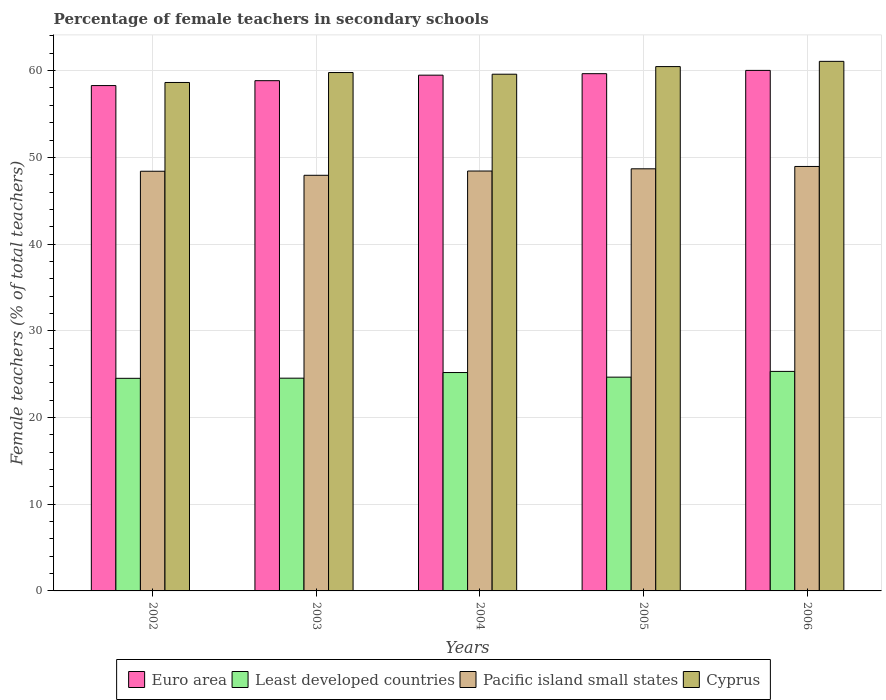How many different coloured bars are there?
Give a very brief answer. 4. Are the number of bars on each tick of the X-axis equal?
Offer a terse response. Yes. How many bars are there on the 5th tick from the left?
Offer a very short reply. 4. What is the label of the 1st group of bars from the left?
Make the answer very short. 2002. In how many cases, is the number of bars for a given year not equal to the number of legend labels?
Provide a short and direct response. 0. What is the percentage of female teachers in Euro area in 2004?
Your answer should be very brief. 59.48. Across all years, what is the maximum percentage of female teachers in Cyprus?
Offer a very short reply. 61.07. Across all years, what is the minimum percentage of female teachers in Least developed countries?
Provide a succinct answer. 24.52. In which year was the percentage of female teachers in Euro area maximum?
Offer a very short reply. 2006. What is the total percentage of female teachers in Least developed countries in the graph?
Provide a short and direct response. 124.2. What is the difference between the percentage of female teachers in Least developed countries in 2002 and that in 2003?
Keep it short and to the point. -0.02. What is the difference between the percentage of female teachers in Least developed countries in 2003 and the percentage of female teachers in Euro area in 2004?
Make the answer very short. -34.94. What is the average percentage of female teachers in Cyprus per year?
Offer a very short reply. 59.91. In the year 2006, what is the difference between the percentage of female teachers in Pacific island small states and percentage of female teachers in Cyprus?
Provide a short and direct response. -12.12. What is the ratio of the percentage of female teachers in Least developed countries in 2003 to that in 2004?
Offer a terse response. 0.97. Is the percentage of female teachers in Least developed countries in 2002 less than that in 2004?
Keep it short and to the point. Yes. Is the difference between the percentage of female teachers in Pacific island small states in 2003 and 2006 greater than the difference between the percentage of female teachers in Cyprus in 2003 and 2006?
Your response must be concise. Yes. What is the difference between the highest and the second highest percentage of female teachers in Cyprus?
Your answer should be very brief. 0.6. What is the difference between the highest and the lowest percentage of female teachers in Cyprus?
Your answer should be very brief. 2.44. In how many years, is the percentage of female teachers in Pacific island small states greater than the average percentage of female teachers in Pacific island small states taken over all years?
Make the answer very short. 2. What does the 2nd bar from the left in 2006 represents?
Offer a very short reply. Least developed countries. What does the 2nd bar from the right in 2003 represents?
Keep it short and to the point. Pacific island small states. Are all the bars in the graph horizontal?
Ensure brevity in your answer.  No. How many years are there in the graph?
Ensure brevity in your answer.  5. What is the difference between two consecutive major ticks on the Y-axis?
Provide a short and direct response. 10. Are the values on the major ticks of Y-axis written in scientific E-notation?
Your answer should be very brief. No. Does the graph contain grids?
Offer a very short reply. Yes. Where does the legend appear in the graph?
Your response must be concise. Bottom center. How many legend labels are there?
Your answer should be compact. 4. How are the legend labels stacked?
Ensure brevity in your answer.  Horizontal. What is the title of the graph?
Your response must be concise. Percentage of female teachers in secondary schools. What is the label or title of the Y-axis?
Make the answer very short. Female teachers (% of total teachers). What is the Female teachers (% of total teachers) in Euro area in 2002?
Ensure brevity in your answer.  58.28. What is the Female teachers (% of total teachers) in Least developed countries in 2002?
Provide a succinct answer. 24.52. What is the Female teachers (% of total teachers) in Pacific island small states in 2002?
Your answer should be compact. 48.4. What is the Female teachers (% of total teachers) in Cyprus in 2002?
Your response must be concise. 58.63. What is the Female teachers (% of total teachers) in Euro area in 2003?
Offer a terse response. 58.84. What is the Female teachers (% of total teachers) of Least developed countries in 2003?
Offer a terse response. 24.53. What is the Female teachers (% of total teachers) of Pacific island small states in 2003?
Provide a short and direct response. 47.93. What is the Female teachers (% of total teachers) in Cyprus in 2003?
Your answer should be compact. 59.78. What is the Female teachers (% of total teachers) of Euro area in 2004?
Provide a succinct answer. 59.48. What is the Female teachers (% of total teachers) in Least developed countries in 2004?
Your answer should be compact. 25.18. What is the Female teachers (% of total teachers) in Pacific island small states in 2004?
Provide a succinct answer. 48.42. What is the Female teachers (% of total teachers) of Cyprus in 2004?
Your answer should be very brief. 59.59. What is the Female teachers (% of total teachers) of Euro area in 2005?
Make the answer very short. 59.65. What is the Female teachers (% of total teachers) of Least developed countries in 2005?
Offer a terse response. 24.65. What is the Female teachers (% of total teachers) of Pacific island small states in 2005?
Offer a very short reply. 48.68. What is the Female teachers (% of total teachers) in Cyprus in 2005?
Offer a terse response. 60.47. What is the Female teachers (% of total teachers) in Euro area in 2006?
Provide a short and direct response. 60.03. What is the Female teachers (% of total teachers) in Least developed countries in 2006?
Offer a terse response. 25.32. What is the Female teachers (% of total teachers) of Pacific island small states in 2006?
Give a very brief answer. 48.95. What is the Female teachers (% of total teachers) of Cyprus in 2006?
Your response must be concise. 61.07. Across all years, what is the maximum Female teachers (% of total teachers) in Euro area?
Your answer should be compact. 60.03. Across all years, what is the maximum Female teachers (% of total teachers) in Least developed countries?
Make the answer very short. 25.32. Across all years, what is the maximum Female teachers (% of total teachers) of Pacific island small states?
Your answer should be very brief. 48.95. Across all years, what is the maximum Female teachers (% of total teachers) in Cyprus?
Your response must be concise. 61.07. Across all years, what is the minimum Female teachers (% of total teachers) in Euro area?
Your answer should be very brief. 58.28. Across all years, what is the minimum Female teachers (% of total teachers) of Least developed countries?
Your answer should be compact. 24.52. Across all years, what is the minimum Female teachers (% of total teachers) in Pacific island small states?
Offer a very short reply. 47.93. Across all years, what is the minimum Female teachers (% of total teachers) in Cyprus?
Your response must be concise. 58.63. What is the total Female teachers (% of total teachers) of Euro area in the graph?
Make the answer very short. 296.28. What is the total Female teachers (% of total teachers) of Least developed countries in the graph?
Offer a terse response. 124.2. What is the total Female teachers (% of total teachers) of Pacific island small states in the graph?
Make the answer very short. 242.38. What is the total Female teachers (% of total teachers) in Cyprus in the graph?
Your response must be concise. 299.54. What is the difference between the Female teachers (% of total teachers) in Euro area in 2002 and that in 2003?
Your answer should be compact. -0.56. What is the difference between the Female teachers (% of total teachers) of Least developed countries in 2002 and that in 2003?
Provide a short and direct response. -0.02. What is the difference between the Female teachers (% of total teachers) in Pacific island small states in 2002 and that in 2003?
Keep it short and to the point. 0.47. What is the difference between the Female teachers (% of total teachers) in Cyprus in 2002 and that in 2003?
Provide a short and direct response. -1.15. What is the difference between the Female teachers (% of total teachers) of Euro area in 2002 and that in 2004?
Provide a short and direct response. -1.2. What is the difference between the Female teachers (% of total teachers) in Least developed countries in 2002 and that in 2004?
Your response must be concise. -0.67. What is the difference between the Female teachers (% of total teachers) of Pacific island small states in 2002 and that in 2004?
Offer a terse response. -0.02. What is the difference between the Female teachers (% of total teachers) of Cyprus in 2002 and that in 2004?
Give a very brief answer. -0.95. What is the difference between the Female teachers (% of total teachers) in Euro area in 2002 and that in 2005?
Your response must be concise. -1.37. What is the difference between the Female teachers (% of total teachers) of Least developed countries in 2002 and that in 2005?
Your answer should be very brief. -0.13. What is the difference between the Female teachers (% of total teachers) in Pacific island small states in 2002 and that in 2005?
Ensure brevity in your answer.  -0.28. What is the difference between the Female teachers (% of total teachers) in Cyprus in 2002 and that in 2005?
Your response must be concise. -1.83. What is the difference between the Female teachers (% of total teachers) in Euro area in 2002 and that in 2006?
Give a very brief answer. -1.75. What is the difference between the Female teachers (% of total teachers) of Least developed countries in 2002 and that in 2006?
Provide a short and direct response. -0.8. What is the difference between the Female teachers (% of total teachers) of Pacific island small states in 2002 and that in 2006?
Offer a terse response. -0.55. What is the difference between the Female teachers (% of total teachers) in Cyprus in 2002 and that in 2006?
Provide a succinct answer. -2.44. What is the difference between the Female teachers (% of total teachers) of Euro area in 2003 and that in 2004?
Make the answer very short. -0.64. What is the difference between the Female teachers (% of total teachers) in Least developed countries in 2003 and that in 2004?
Give a very brief answer. -0.65. What is the difference between the Female teachers (% of total teachers) in Pacific island small states in 2003 and that in 2004?
Offer a very short reply. -0.49. What is the difference between the Female teachers (% of total teachers) in Cyprus in 2003 and that in 2004?
Give a very brief answer. 0.19. What is the difference between the Female teachers (% of total teachers) in Euro area in 2003 and that in 2005?
Provide a succinct answer. -0.81. What is the difference between the Female teachers (% of total teachers) of Least developed countries in 2003 and that in 2005?
Keep it short and to the point. -0.12. What is the difference between the Female teachers (% of total teachers) of Pacific island small states in 2003 and that in 2005?
Your response must be concise. -0.75. What is the difference between the Female teachers (% of total teachers) in Cyprus in 2003 and that in 2005?
Offer a terse response. -0.69. What is the difference between the Female teachers (% of total teachers) in Euro area in 2003 and that in 2006?
Keep it short and to the point. -1.19. What is the difference between the Female teachers (% of total teachers) in Least developed countries in 2003 and that in 2006?
Give a very brief answer. -0.78. What is the difference between the Female teachers (% of total teachers) in Pacific island small states in 2003 and that in 2006?
Provide a short and direct response. -1.02. What is the difference between the Female teachers (% of total teachers) of Cyprus in 2003 and that in 2006?
Offer a very short reply. -1.29. What is the difference between the Female teachers (% of total teachers) in Euro area in 2004 and that in 2005?
Provide a short and direct response. -0.17. What is the difference between the Female teachers (% of total teachers) of Least developed countries in 2004 and that in 2005?
Offer a very short reply. 0.53. What is the difference between the Female teachers (% of total teachers) of Pacific island small states in 2004 and that in 2005?
Your answer should be very brief. -0.26. What is the difference between the Female teachers (% of total teachers) in Cyprus in 2004 and that in 2005?
Give a very brief answer. -0.88. What is the difference between the Female teachers (% of total teachers) in Euro area in 2004 and that in 2006?
Your answer should be compact. -0.55. What is the difference between the Female teachers (% of total teachers) of Least developed countries in 2004 and that in 2006?
Your answer should be very brief. -0.13. What is the difference between the Female teachers (% of total teachers) in Pacific island small states in 2004 and that in 2006?
Provide a short and direct response. -0.53. What is the difference between the Female teachers (% of total teachers) of Cyprus in 2004 and that in 2006?
Your answer should be very brief. -1.48. What is the difference between the Female teachers (% of total teachers) of Euro area in 2005 and that in 2006?
Offer a very short reply. -0.38. What is the difference between the Female teachers (% of total teachers) of Least developed countries in 2005 and that in 2006?
Keep it short and to the point. -0.66. What is the difference between the Female teachers (% of total teachers) of Pacific island small states in 2005 and that in 2006?
Your answer should be compact. -0.27. What is the difference between the Female teachers (% of total teachers) in Cyprus in 2005 and that in 2006?
Your answer should be compact. -0.6. What is the difference between the Female teachers (% of total teachers) in Euro area in 2002 and the Female teachers (% of total teachers) in Least developed countries in 2003?
Provide a short and direct response. 33.74. What is the difference between the Female teachers (% of total teachers) in Euro area in 2002 and the Female teachers (% of total teachers) in Pacific island small states in 2003?
Ensure brevity in your answer.  10.35. What is the difference between the Female teachers (% of total teachers) of Euro area in 2002 and the Female teachers (% of total teachers) of Cyprus in 2003?
Your answer should be very brief. -1.5. What is the difference between the Female teachers (% of total teachers) of Least developed countries in 2002 and the Female teachers (% of total teachers) of Pacific island small states in 2003?
Make the answer very short. -23.41. What is the difference between the Female teachers (% of total teachers) in Least developed countries in 2002 and the Female teachers (% of total teachers) in Cyprus in 2003?
Offer a terse response. -35.26. What is the difference between the Female teachers (% of total teachers) in Pacific island small states in 2002 and the Female teachers (% of total teachers) in Cyprus in 2003?
Provide a succinct answer. -11.38. What is the difference between the Female teachers (% of total teachers) in Euro area in 2002 and the Female teachers (% of total teachers) in Least developed countries in 2004?
Make the answer very short. 33.09. What is the difference between the Female teachers (% of total teachers) in Euro area in 2002 and the Female teachers (% of total teachers) in Pacific island small states in 2004?
Offer a very short reply. 9.85. What is the difference between the Female teachers (% of total teachers) in Euro area in 2002 and the Female teachers (% of total teachers) in Cyprus in 2004?
Make the answer very short. -1.31. What is the difference between the Female teachers (% of total teachers) of Least developed countries in 2002 and the Female teachers (% of total teachers) of Pacific island small states in 2004?
Your answer should be very brief. -23.91. What is the difference between the Female teachers (% of total teachers) of Least developed countries in 2002 and the Female teachers (% of total teachers) of Cyprus in 2004?
Ensure brevity in your answer.  -35.07. What is the difference between the Female teachers (% of total teachers) in Pacific island small states in 2002 and the Female teachers (% of total teachers) in Cyprus in 2004?
Your answer should be compact. -11.19. What is the difference between the Female teachers (% of total teachers) of Euro area in 2002 and the Female teachers (% of total teachers) of Least developed countries in 2005?
Your response must be concise. 33.62. What is the difference between the Female teachers (% of total teachers) in Euro area in 2002 and the Female teachers (% of total teachers) in Pacific island small states in 2005?
Provide a short and direct response. 9.6. What is the difference between the Female teachers (% of total teachers) in Euro area in 2002 and the Female teachers (% of total teachers) in Cyprus in 2005?
Give a very brief answer. -2.19. What is the difference between the Female teachers (% of total teachers) of Least developed countries in 2002 and the Female teachers (% of total teachers) of Pacific island small states in 2005?
Provide a succinct answer. -24.16. What is the difference between the Female teachers (% of total teachers) in Least developed countries in 2002 and the Female teachers (% of total teachers) in Cyprus in 2005?
Provide a succinct answer. -35.95. What is the difference between the Female teachers (% of total teachers) in Pacific island small states in 2002 and the Female teachers (% of total teachers) in Cyprus in 2005?
Ensure brevity in your answer.  -12.07. What is the difference between the Female teachers (% of total teachers) of Euro area in 2002 and the Female teachers (% of total teachers) of Least developed countries in 2006?
Your response must be concise. 32.96. What is the difference between the Female teachers (% of total teachers) of Euro area in 2002 and the Female teachers (% of total teachers) of Pacific island small states in 2006?
Your response must be concise. 9.33. What is the difference between the Female teachers (% of total teachers) in Euro area in 2002 and the Female teachers (% of total teachers) in Cyprus in 2006?
Offer a very short reply. -2.79. What is the difference between the Female teachers (% of total teachers) in Least developed countries in 2002 and the Female teachers (% of total teachers) in Pacific island small states in 2006?
Give a very brief answer. -24.43. What is the difference between the Female teachers (% of total teachers) of Least developed countries in 2002 and the Female teachers (% of total teachers) of Cyprus in 2006?
Your answer should be compact. -36.55. What is the difference between the Female teachers (% of total teachers) of Pacific island small states in 2002 and the Female teachers (% of total teachers) of Cyprus in 2006?
Your answer should be compact. -12.67. What is the difference between the Female teachers (% of total teachers) of Euro area in 2003 and the Female teachers (% of total teachers) of Least developed countries in 2004?
Your answer should be very brief. 33.66. What is the difference between the Female teachers (% of total teachers) of Euro area in 2003 and the Female teachers (% of total teachers) of Pacific island small states in 2004?
Offer a very short reply. 10.42. What is the difference between the Female teachers (% of total teachers) in Euro area in 2003 and the Female teachers (% of total teachers) in Cyprus in 2004?
Keep it short and to the point. -0.75. What is the difference between the Female teachers (% of total teachers) in Least developed countries in 2003 and the Female teachers (% of total teachers) in Pacific island small states in 2004?
Keep it short and to the point. -23.89. What is the difference between the Female teachers (% of total teachers) of Least developed countries in 2003 and the Female teachers (% of total teachers) of Cyprus in 2004?
Keep it short and to the point. -35.06. What is the difference between the Female teachers (% of total teachers) of Pacific island small states in 2003 and the Female teachers (% of total teachers) of Cyprus in 2004?
Your response must be concise. -11.66. What is the difference between the Female teachers (% of total teachers) in Euro area in 2003 and the Female teachers (% of total teachers) in Least developed countries in 2005?
Offer a terse response. 34.19. What is the difference between the Female teachers (% of total teachers) in Euro area in 2003 and the Female teachers (% of total teachers) in Pacific island small states in 2005?
Your answer should be very brief. 10.16. What is the difference between the Female teachers (% of total teachers) of Euro area in 2003 and the Female teachers (% of total teachers) of Cyprus in 2005?
Ensure brevity in your answer.  -1.63. What is the difference between the Female teachers (% of total teachers) in Least developed countries in 2003 and the Female teachers (% of total teachers) in Pacific island small states in 2005?
Offer a terse response. -24.15. What is the difference between the Female teachers (% of total teachers) in Least developed countries in 2003 and the Female teachers (% of total teachers) in Cyprus in 2005?
Keep it short and to the point. -35.93. What is the difference between the Female teachers (% of total teachers) in Pacific island small states in 2003 and the Female teachers (% of total teachers) in Cyprus in 2005?
Provide a succinct answer. -12.54. What is the difference between the Female teachers (% of total teachers) of Euro area in 2003 and the Female teachers (% of total teachers) of Least developed countries in 2006?
Your response must be concise. 33.53. What is the difference between the Female teachers (% of total teachers) in Euro area in 2003 and the Female teachers (% of total teachers) in Pacific island small states in 2006?
Give a very brief answer. 9.89. What is the difference between the Female teachers (% of total teachers) in Euro area in 2003 and the Female teachers (% of total teachers) in Cyprus in 2006?
Provide a short and direct response. -2.23. What is the difference between the Female teachers (% of total teachers) of Least developed countries in 2003 and the Female teachers (% of total teachers) of Pacific island small states in 2006?
Make the answer very short. -24.42. What is the difference between the Female teachers (% of total teachers) of Least developed countries in 2003 and the Female teachers (% of total teachers) of Cyprus in 2006?
Offer a very short reply. -36.54. What is the difference between the Female teachers (% of total teachers) in Pacific island small states in 2003 and the Female teachers (% of total teachers) in Cyprus in 2006?
Your answer should be very brief. -13.14. What is the difference between the Female teachers (% of total teachers) in Euro area in 2004 and the Female teachers (% of total teachers) in Least developed countries in 2005?
Give a very brief answer. 34.83. What is the difference between the Female teachers (% of total teachers) of Euro area in 2004 and the Female teachers (% of total teachers) of Pacific island small states in 2005?
Ensure brevity in your answer.  10.8. What is the difference between the Female teachers (% of total teachers) of Euro area in 2004 and the Female teachers (% of total teachers) of Cyprus in 2005?
Keep it short and to the point. -0.99. What is the difference between the Female teachers (% of total teachers) in Least developed countries in 2004 and the Female teachers (% of total teachers) in Pacific island small states in 2005?
Offer a terse response. -23.49. What is the difference between the Female teachers (% of total teachers) in Least developed countries in 2004 and the Female teachers (% of total teachers) in Cyprus in 2005?
Provide a succinct answer. -35.28. What is the difference between the Female teachers (% of total teachers) in Pacific island small states in 2004 and the Female teachers (% of total teachers) in Cyprus in 2005?
Your answer should be compact. -12.04. What is the difference between the Female teachers (% of total teachers) of Euro area in 2004 and the Female teachers (% of total teachers) of Least developed countries in 2006?
Keep it short and to the point. 34.16. What is the difference between the Female teachers (% of total teachers) of Euro area in 2004 and the Female teachers (% of total teachers) of Pacific island small states in 2006?
Your response must be concise. 10.53. What is the difference between the Female teachers (% of total teachers) of Euro area in 2004 and the Female teachers (% of total teachers) of Cyprus in 2006?
Make the answer very short. -1.59. What is the difference between the Female teachers (% of total teachers) in Least developed countries in 2004 and the Female teachers (% of total teachers) in Pacific island small states in 2006?
Provide a short and direct response. -23.77. What is the difference between the Female teachers (% of total teachers) in Least developed countries in 2004 and the Female teachers (% of total teachers) in Cyprus in 2006?
Make the answer very short. -35.89. What is the difference between the Female teachers (% of total teachers) of Pacific island small states in 2004 and the Female teachers (% of total teachers) of Cyprus in 2006?
Your answer should be very brief. -12.65. What is the difference between the Female teachers (% of total teachers) in Euro area in 2005 and the Female teachers (% of total teachers) in Least developed countries in 2006?
Keep it short and to the point. 34.33. What is the difference between the Female teachers (% of total teachers) in Euro area in 2005 and the Female teachers (% of total teachers) in Pacific island small states in 2006?
Make the answer very short. 10.7. What is the difference between the Female teachers (% of total teachers) in Euro area in 2005 and the Female teachers (% of total teachers) in Cyprus in 2006?
Offer a terse response. -1.42. What is the difference between the Female teachers (% of total teachers) in Least developed countries in 2005 and the Female teachers (% of total teachers) in Pacific island small states in 2006?
Make the answer very short. -24.3. What is the difference between the Female teachers (% of total teachers) of Least developed countries in 2005 and the Female teachers (% of total teachers) of Cyprus in 2006?
Provide a short and direct response. -36.42. What is the difference between the Female teachers (% of total teachers) of Pacific island small states in 2005 and the Female teachers (% of total teachers) of Cyprus in 2006?
Your answer should be very brief. -12.39. What is the average Female teachers (% of total teachers) in Euro area per year?
Ensure brevity in your answer.  59.26. What is the average Female teachers (% of total teachers) in Least developed countries per year?
Give a very brief answer. 24.84. What is the average Female teachers (% of total teachers) of Pacific island small states per year?
Offer a terse response. 48.48. What is the average Female teachers (% of total teachers) of Cyprus per year?
Keep it short and to the point. 59.91. In the year 2002, what is the difference between the Female teachers (% of total teachers) in Euro area and Female teachers (% of total teachers) in Least developed countries?
Your answer should be very brief. 33.76. In the year 2002, what is the difference between the Female teachers (% of total teachers) of Euro area and Female teachers (% of total teachers) of Pacific island small states?
Give a very brief answer. 9.88. In the year 2002, what is the difference between the Female teachers (% of total teachers) of Euro area and Female teachers (% of total teachers) of Cyprus?
Provide a succinct answer. -0.36. In the year 2002, what is the difference between the Female teachers (% of total teachers) of Least developed countries and Female teachers (% of total teachers) of Pacific island small states?
Your answer should be compact. -23.88. In the year 2002, what is the difference between the Female teachers (% of total teachers) in Least developed countries and Female teachers (% of total teachers) in Cyprus?
Make the answer very short. -34.12. In the year 2002, what is the difference between the Female teachers (% of total teachers) of Pacific island small states and Female teachers (% of total teachers) of Cyprus?
Ensure brevity in your answer.  -10.24. In the year 2003, what is the difference between the Female teachers (% of total teachers) in Euro area and Female teachers (% of total teachers) in Least developed countries?
Your response must be concise. 34.31. In the year 2003, what is the difference between the Female teachers (% of total teachers) in Euro area and Female teachers (% of total teachers) in Pacific island small states?
Offer a terse response. 10.91. In the year 2003, what is the difference between the Female teachers (% of total teachers) of Euro area and Female teachers (% of total teachers) of Cyprus?
Make the answer very short. -0.94. In the year 2003, what is the difference between the Female teachers (% of total teachers) of Least developed countries and Female teachers (% of total teachers) of Pacific island small states?
Make the answer very short. -23.4. In the year 2003, what is the difference between the Female teachers (% of total teachers) in Least developed countries and Female teachers (% of total teachers) in Cyprus?
Your answer should be compact. -35.25. In the year 2003, what is the difference between the Female teachers (% of total teachers) in Pacific island small states and Female teachers (% of total teachers) in Cyprus?
Provide a short and direct response. -11.85. In the year 2004, what is the difference between the Female teachers (% of total teachers) in Euro area and Female teachers (% of total teachers) in Least developed countries?
Make the answer very short. 34.29. In the year 2004, what is the difference between the Female teachers (% of total teachers) of Euro area and Female teachers (% of total teachers) of Pacific island small states?
Offer a very short reply. 11.05. In the year 2004, what is the difference between the Female teachers (% of total teachers) of Euro area and Female teachers (% of total teachers) of Cyprus?
Keep it short and to the point. -0.11. In the year 2004, what is the difference between the Female teachers (% of total teachers) of Least developed countries and Female teachers (% of total teachers) of Pacific island small states?
Ensure brevity in your answer.  -23.24. In the year 2004, what is the difference between the Female teachers (% of total teachers) of Least developed countries and Female teachers (% of total teachers) of Cyprus?
Give a very brief answer. -34.4. In the year 2004, what is the difference between the Female teachers (% of total teachers) in Pacific island small states and Female teachers (% of total teachers) in Cyprus?
Make the answer very short. -11.16. In the year 2005, what is the difference between the Female teachers (% of total teachers) of Euro area and Female teachers (% of total teachers) of Least developed countries?
Keep it short and to the point. 35. In the year 2005, what is the difference between the Female teachers (% of total teachers) of Euro area and Female teachers (% of total teachers) of Pacific island small states?
Offer a terse response. 10.97. In the year 2005, what is the difference between the Female teachers (% of total teachers) in Euro area and Female teachers (% of total teachers) in Cyprus?
Give a very brief answer. -0.82. In the year 2005, what is the difference between the Female teachers (% of total teachers) of Least developed countries and Female teachers (% of total teachers) of Pacific island small states?
Keep it short and to the point. -24.03. In the year 2005, what is the difference between the Female teachers (% of total teachers) in Least developed countries and Female teachers (% of total teachers) in Cyprus?
Give a very brief answer. -35.81. In the year 2005, what is the difference between the Female teachers (% of total teachers) of Pacific island small states and Female teachers (% of total teachers) of Cyprus?
Ensure brevity in your answer.  -11.79. In the year 2006, what is the difference between the Female teachers (% of total teachers) of Euro area and Female teachers (% of total teachers) of Least developed countries?
Ensure brevity in your answer.  34.71. In the year 2006, what is the difference between the Female teachers (% of total teachers) of Euro area and Female teachers (% of total teachers) of Pacific island small states?
Offer a very short reply. 11.08. In the year 2006, what is the difference between the Female teachers (% of total teachers) in Euro area and Female teachers (% of total teachers) in Cyprus?
Your response must be concise. -1.04. In the year 2006, what is the difference between the Female teachers (% of total teachers) of Least developed countries and Female teachers (% of total teachers) of Pacific island small states?
Your response must be concise. -23.63. In the year 2006, what is the difference between the Female teachers (% of total teachers) in Least developed countries and Female teachers (% of total teachers) in Cyprus?
Provide a succinct answer. -35.76. In the year 2006, what is the difference between the Female teachers (% of total teachers) of Pacific island small states and Female teachers (% of total teachers) of Cyprus?
Your answer should be compact. -12.12. What is the ratio of the Female teachers (% of total teachers) in Least developed countries in 2002 to that in 2003?
Offer a very short reply. 1. What is the ratio of the Female teachers (% of total teachers) in Pacific island small states in 2002 to that in 2003?
Provide a succinct answer. 1.01. What is the ratio of the Female teachers (% of total teachers) in Cyprus in 2002 to that in 2003?
Ensure brevity in your answer.  0.98. What is the ratio of the Female teachers (% of total teachers) in Euro area in 2002 to that in 2004?
Give a very brief answer. 0.98. What is the ratio of the Female teachers (% of total teachers) in Least developed countries in 2002 to that in 2004?
Keep it short and to the point. 0.97. What is the ratio of the Female teachers (% of total teachers) in Pacific island small states in 2002 to that in 2004?
Your answer should be very brief. 1. What is the ratio of the Female teachers (% of total teachers) of Cyprus in 2002 to that in 2004?
Make the answer very short. 0.98. What is the ratio of the Female teachers (% of total teachers) in Least developed countries in 2002 to that in 2005?
Offer a terse response. 0.99. What is the ratio of the Female teachers (% of total teachers) of Pacific island small states in 2002 to that in 2005?
Your answer should be compact. 0.99. What is the ratio of the Female teachers (% of total teachers) in Cyprus in 2002 to that in 2005?
Ensure brevity in your answer.  0.97. What is the ratio of the Female teachers (% of total teachers) of Euro area in 2002 to that in 2006?
Your answer should be very brief. 0.97. What is the ratio of the Female teachers (% of total teachers) of Least developed countries in 2002 to that in 2006?
Provide a succinct answer. 0.97. What is the ratio of the Female teachers (% of total teachers) in Cyprus in 2002 to that in 2006?
Your answer should be very brief. 0.96. What is the ratio of the Female teachers (% of total teachers) of Euro area in 2003 to that in 2004?
Your answer should be very brief. 0.99. What is the ratio of the Female teachers (% of total teachers) of Least developed countries in 2003 to that in 2004?
Offer a terse response. 0.97. What is the ratio of the Female teachers (% of total teachers) of Euro area in 2003 to that in 2005?
Offer a very short reply. 0.99. What is the ratio of the Female teachers (% of total teachers) in Pacific island small states in 2003 to that in 2005?
Give a very brief answer. 0.98. What is the ratio of the Female teachers (% of total teachers) of Cyprus in 2003 to that in 2005?
Keep it short and to the point. 0.99. What is the ratio of the Female teachers (% of total teachers) of Euro area in 2003 to that in 2006?
Provide a succinct answer. 0.98. What is the ratio of the Female teachers (% of total teachers) of Least developed countries in 2003 to that in 2006?
Provide a succinct answer. 0.97. What is the ratio of the Female teachers (% of total teachers) in Pacific island small states in 2003 to that in 2006?
Keep it short and to the point. 0.98. What is the ratio of the Female teachers (% of total teachers) in Cyprus in 2003 to that in 2006?
Your response must be concise. 0.98. What is the ratio of the Female teachers (% of total teachers) in Euro area in 2004 to that in 2005?
Offer a terse response. 1. What is the ratio of the Female teachers (% of total teachers) of Least developed countries in 2004 to that in 2005?
Give a very brief answer. 1.02. What is the ratio of the Female teachers (% of total teachers) in Pacific island small states in 2004 to that in 2005?
Your response must be concise. 0.99. What is the ratio of the Female teachers (% of total teachers) of Cyprus in 2004 to that in 2005?
Offer a terse response. 0.99. What is the ratio of the Female teachers (% of total teachers) of Euro area in 2004 to that in 2006?
Your answer should be very brief. 0.99. What is the ratio of the Female teachers (% of total teachers) of Pacific island small states in 2004 to that in 2006?
Give a very brief answer. 0.99. What is the ratio of the Female teachers (% of total teachers) of Cyprus in 2004 to that in 2006?
Make the answer very short. 0.98. What is the ratio of the Female teachers (% of total teachers) of Euro area in 2005 to that in 2006?
Your response must be concise. 0.99. What is the ratio of the Female teachers (% of total teachers) of Least developed countries in 2005 to that in 2006?
Provide a succinct answer. 0.97. What is the ratio of the Female teachers (% of total teachers) in Cyprus in 2005 to that in 2006?
Keep it short and to the point. 0.99. What is the difference between the highest and the second highest Female teachers (% of total teachers) of Euro area?
Provide a short and direct response. 0.38. What is the difference between the highest and the second highest Female teachers (% of total teachers) of Least developed countries?
Your answer should be compact. 0.13. What is the difference between the highest and the second highest Female teachers (% of total teachers) in Pacific island small states?
Offer a very short reply. 0.27. What is the difference between the highest and the second highest Female teachers (% of total teachers) in Cyprus?
Ensure brevity in your answer.  0.6. What is the difference between the highest and the lowest Female teachers (% of total teachers) of Euro area?
Your answer should be compact. 1.75. What is the difference between the highest and the lowest Female teachers (% of total teachers) in Least developed countries?
Offer a terse response. 0.8. What is the difference between the highest and the lowest Female teachers (% of total teachers) in Pacific island small states?
Provide a succinct answer. 1.02. What is the difference between the highest and the lowest Female teachers (% of total teachers) of Cyprus?
Offer a terse response. 2.44. 